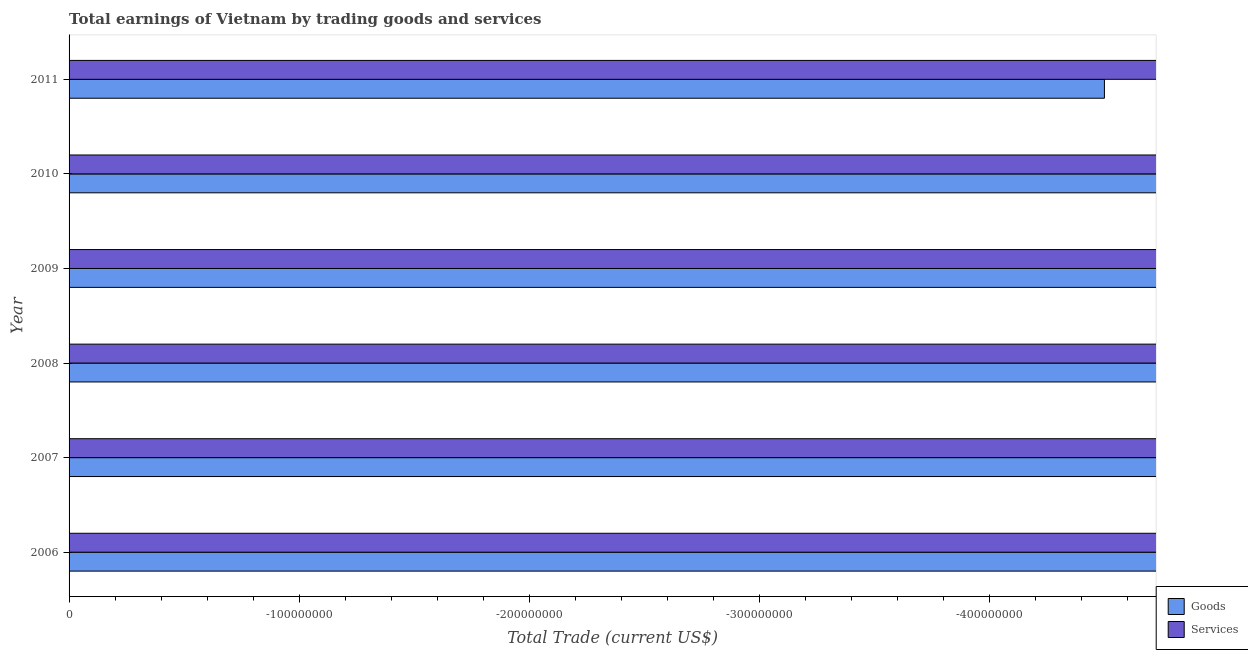Are the number of bars per tick equal to the number of legend labels?
Your response must be concise. No. What is the difference between the amount earned by trading services in 2006 and the amount earned by trading goods in 2007?
Your answer should be compact. 0. What is the average amount earned by trading services per year?
Provide a succinct answer. 0. In how many years, is the amount earned by trading services greater than the average amount earned by trading services taken over all years?
Keep it short and to the point. 0. How many bars are there?
Ensure brevity in your answer.  0. How many years are there in the graph?
Your response must be concise. 6. What is the difference between two consecutive major ticks on the X-axis?
Your answer should be compact. 1.00e+08. Are the values on the major ticks of X-axis written in scientific E-notation?
Ensure brevity in your answer.  No. Does the graph contain any zero values?
Your answer should be compact. Yes. Does the graph contain grids?
Your answer should be very brief. No. What is the title of the graph?
Offer a very short reply. Total earnings of Vietnam by trading goods and services. What is the label or title of the X-axis?
Keep it short and to the point. Total Trade (current US$). What is the label or title of the Y-axis?
Provide a short and direct response. Year. What is the Total Trade (current US$) of Goods in 2006?
Your response must be concise. 0. What is the Total Trade (current US$) in Services in 2007?
Give a very brief answer. 0. What is the Total Trade (current US$) of Goods in 2008?
Keep it short and to the point. 0. What is the Total Trade (current US$) in Services in 2009?
Keep it short and to the point. 0. What is the Total Trade (current US$) of Goods in 2010?
Your answer should be very brief. 0. What is the Total Trade (current US$) in Services in 2011?
Provide a short and direct response. 0. What is the total Total Trade (current US$) in Goods in the graph?
Provide a short and direct response. 0. What is the total Total Trade (current US$) in Services in the graph?
Your answer should be very brief. 0. What is the average Total Trade (current US$) of Goods per year?
Give a very brief answer. 0. 